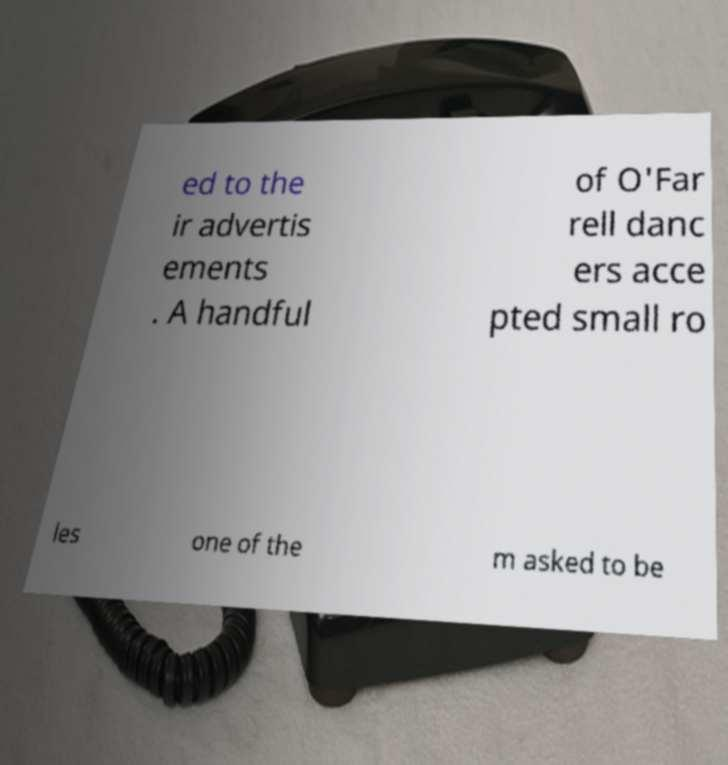There's text embedded in this image that I need extracted. Can you transcribe it verbatim? ed to the ir advertis ements . A handful of O'Far rell danc ers acce pted small ro les one of the m asked to be 